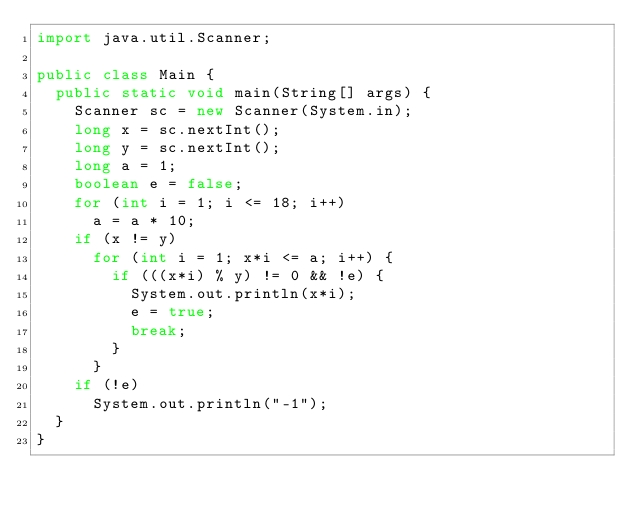<code> <loc_0><loc_0><loc_500><loc_500><_Java_>import java.util.Scanner;

public class Main {
	public static void main(String[] args) {
		Scanner sc = new Scanner(System.in);
		long x = sc.nextInt();
		long y = sc.nextInt();
		long a = 1;
		boolean e = false;
		for (int i = 1; i <= 18; i++)
			a = a * 10;
		if (x != y)
			for (int i = 1; x*i <= a; i++) {
				if (((x*i) % y) != 0 && !e) {
					System.out.println(x*i);
					e = true;
					break;
				}
			}
		if (!e)
			System.out.println("-1");
	}
}</code> 